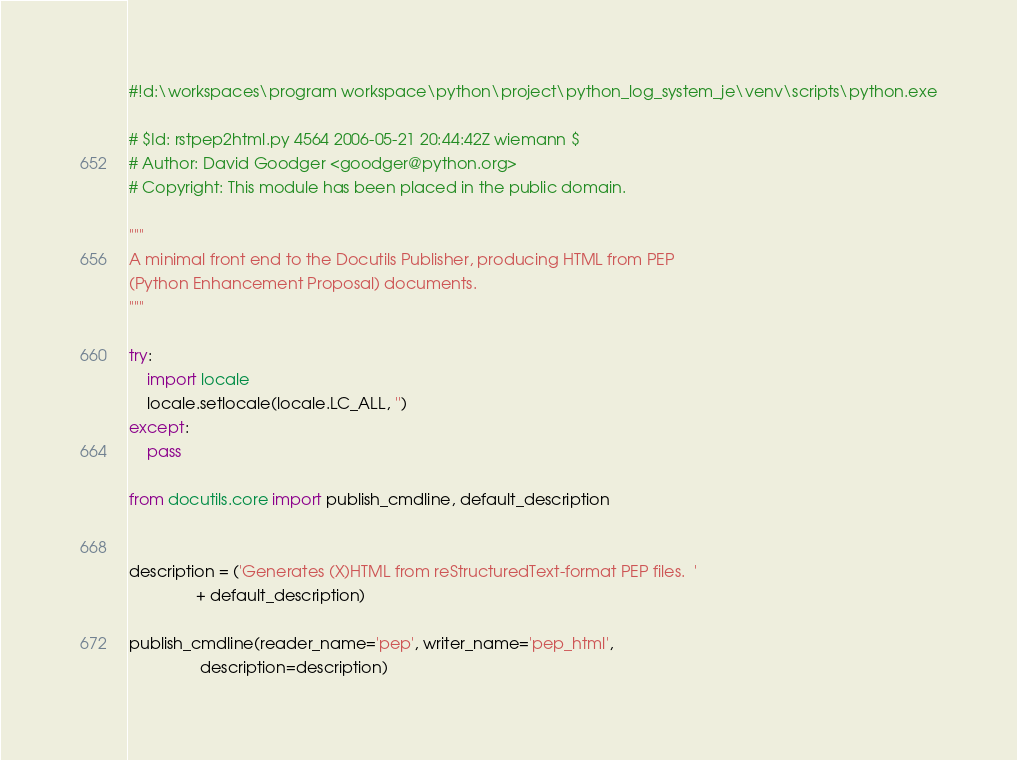Convert code to text. <code><loc_0><loc_0><loc_500><loc_500><_Python_>#!d:\workspaces\program workspace\python\project\python_log_system_je\venv\scripts\python.exe

# $Id: rstpep2html.py 4564 2006-05-21 20:44:42Z wiemann $
# Author: David Goodger <goodger@python.org>
# Copyright: This module has been placed in the public domain.

"""
A minimal front end to the Docutils Publisher, producing HTML from PEP
(Python Enhancement Proposal) documents.
"""

try:
    import locale
    locale.setlocale(locale.LC_ALL, '')
except:
    pass

from docutils.core import publish_cmdline, default_description


description = ('Generates (X)HTML from reStructuredText-format PEP files.  '
               + default_description)

publish_cmdline(reader_name='pep', writer_name='pep_html',
                description=description)
</code> 